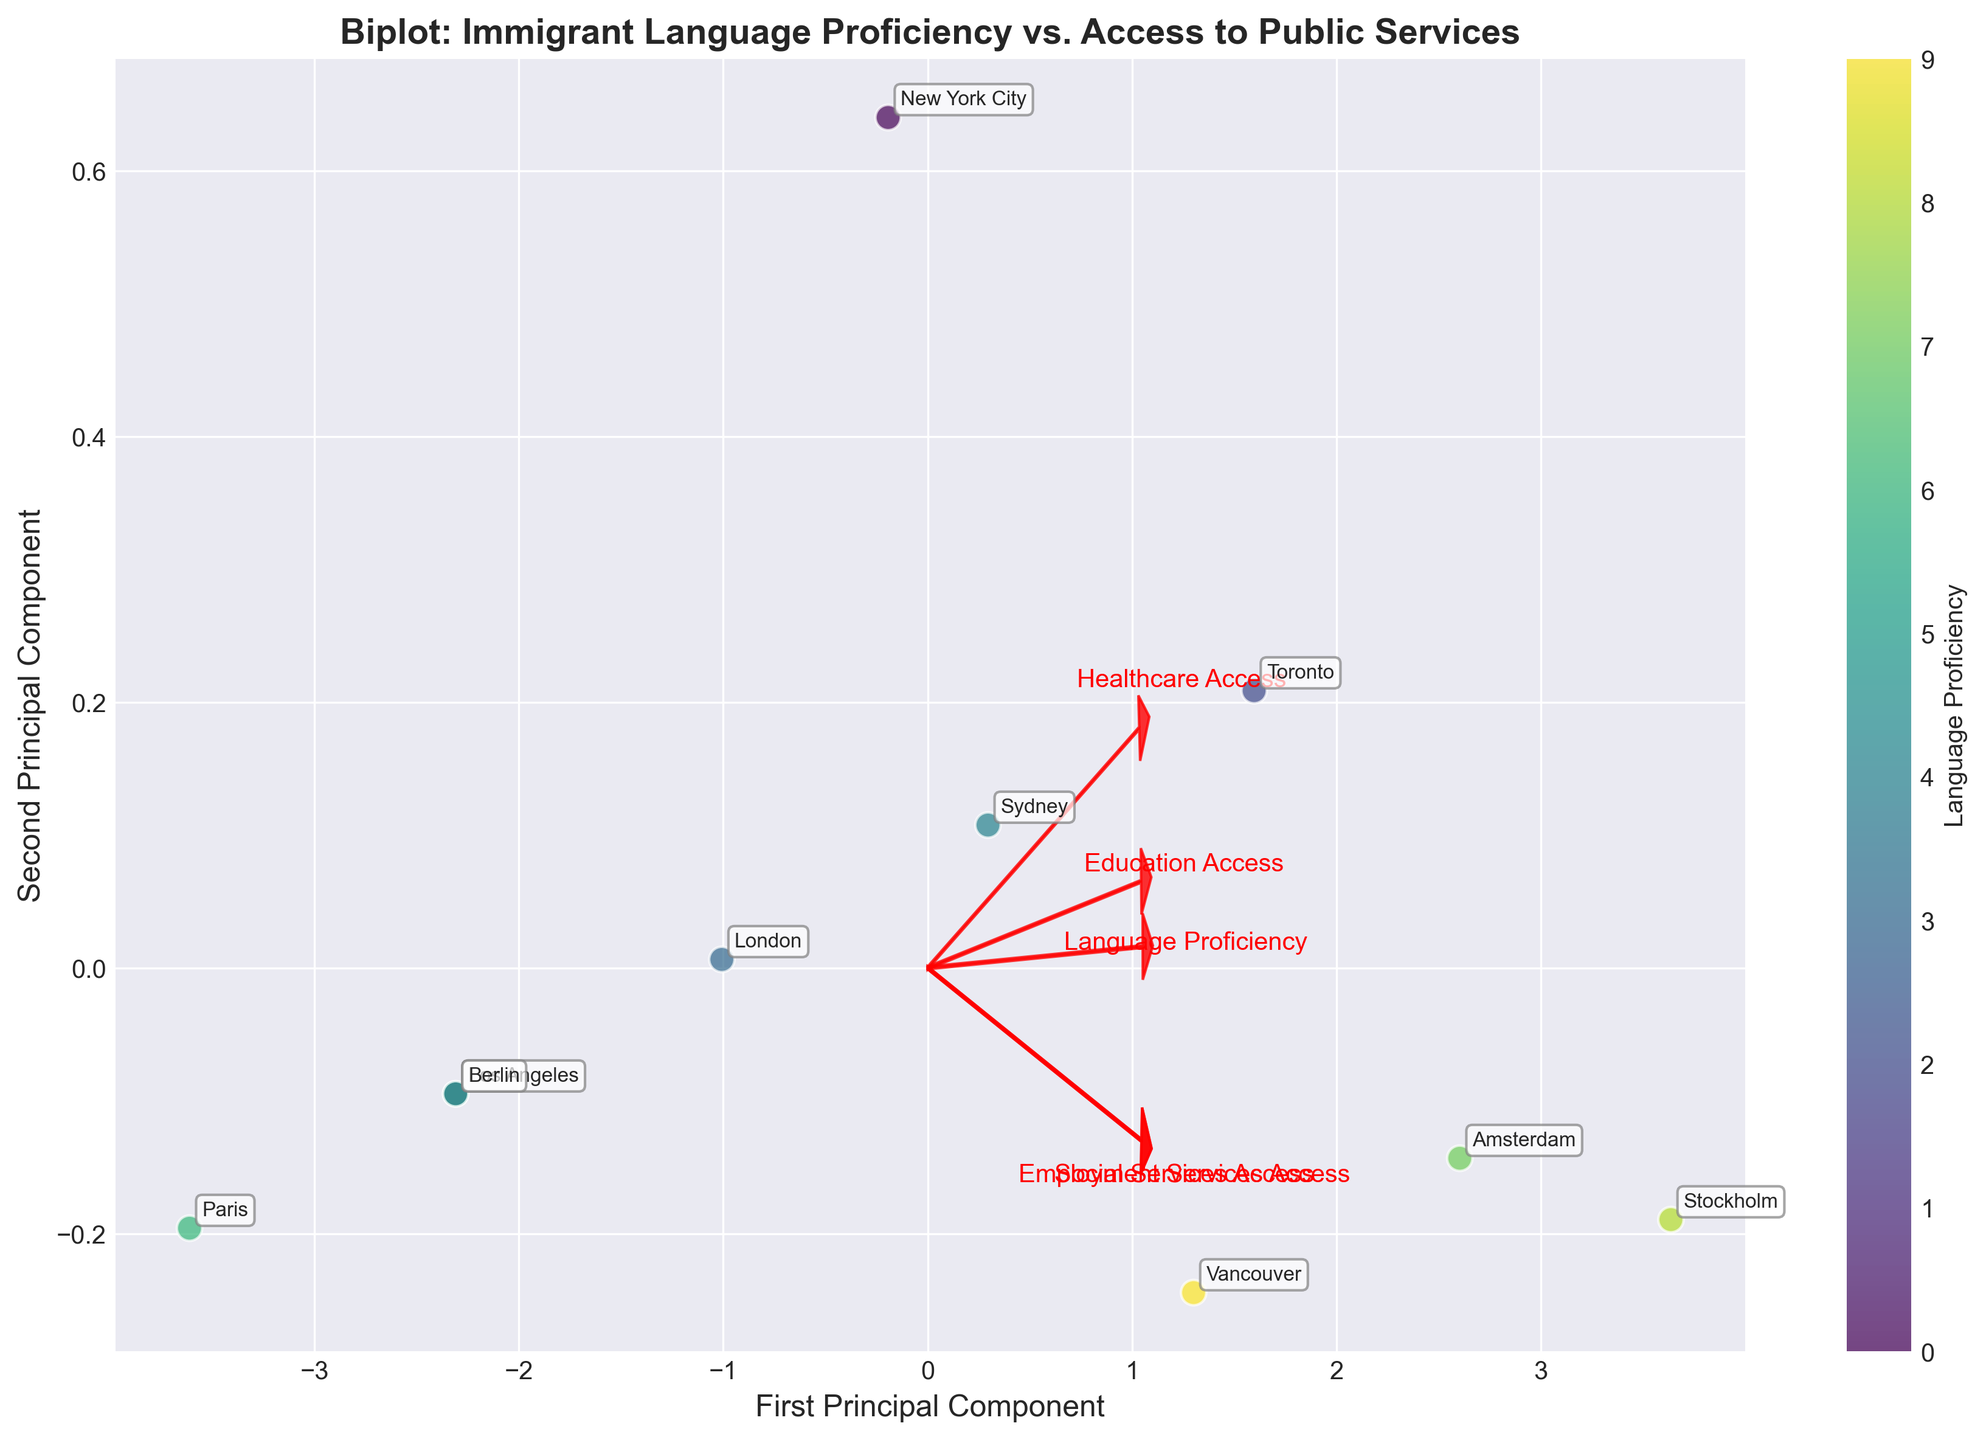What is the title of the biplot? The title of the biplot can be found at the top of the figure where it provides a summary of what the plot is about.
Answer: Biplot: Immigrant Language Proficiency vs. Access to Public Services How many regions are represented in this biplot? You can determine the number of regions by counting the different labeled points in the plot.
Answer: 10 Which region has the highest language proficiency? The region with the highest language proficiency will be represented by the point that has the highest value in the color bar.
Answer: Stockholm How does the healthcare access in Amsterdam compare to that in New York City? The arrows representing different public services can be compared for a particular region by seeing where the points lie relative to the vectors’ directions. Healthcare access for Amsterdam appears to be higher, given Amsterdam's position relative to the healthcare access vector.
Answer: Amsterdam has higher healthcare access than New York City Which services are most strongly associated with language proficiency? The direction and length of the arrows representing the different access services indicate their association with language proficiency. Longer arrows in the same direction as language proficiency suggest a stronger association.
Answer: Education Access Are there any regions where social services access is below 0.75? To determine this, you can examine the points' positions relative to the social services access arrow and their placement on the chart.
Answer: Paris and Berlin Is there a noticeable trend between language proficiency and education access? By observing the direction and length of the arrows, we can infer if there is a trend based on how points align with both variables.
Answer: Yes, there is a positive trend Which principal component explains more variation in the data? This can be inferred by looking at the axes labels and the amount of spread or clustering of the data along the respective axes.
Answer: First Principal Component What region is closest to the mean of the dataset in the biplot? The mean of the dataset in a biplot is denoted by the origin (0,0), and the closest point to this will represent the region.
Answer: New York City In which region is employment services access the lowest? To find this, compare the placement of regions relative to the employment services access vector. The region farthest away in the negative direction along this vector indicates the lowest access.
Answer: Paris 